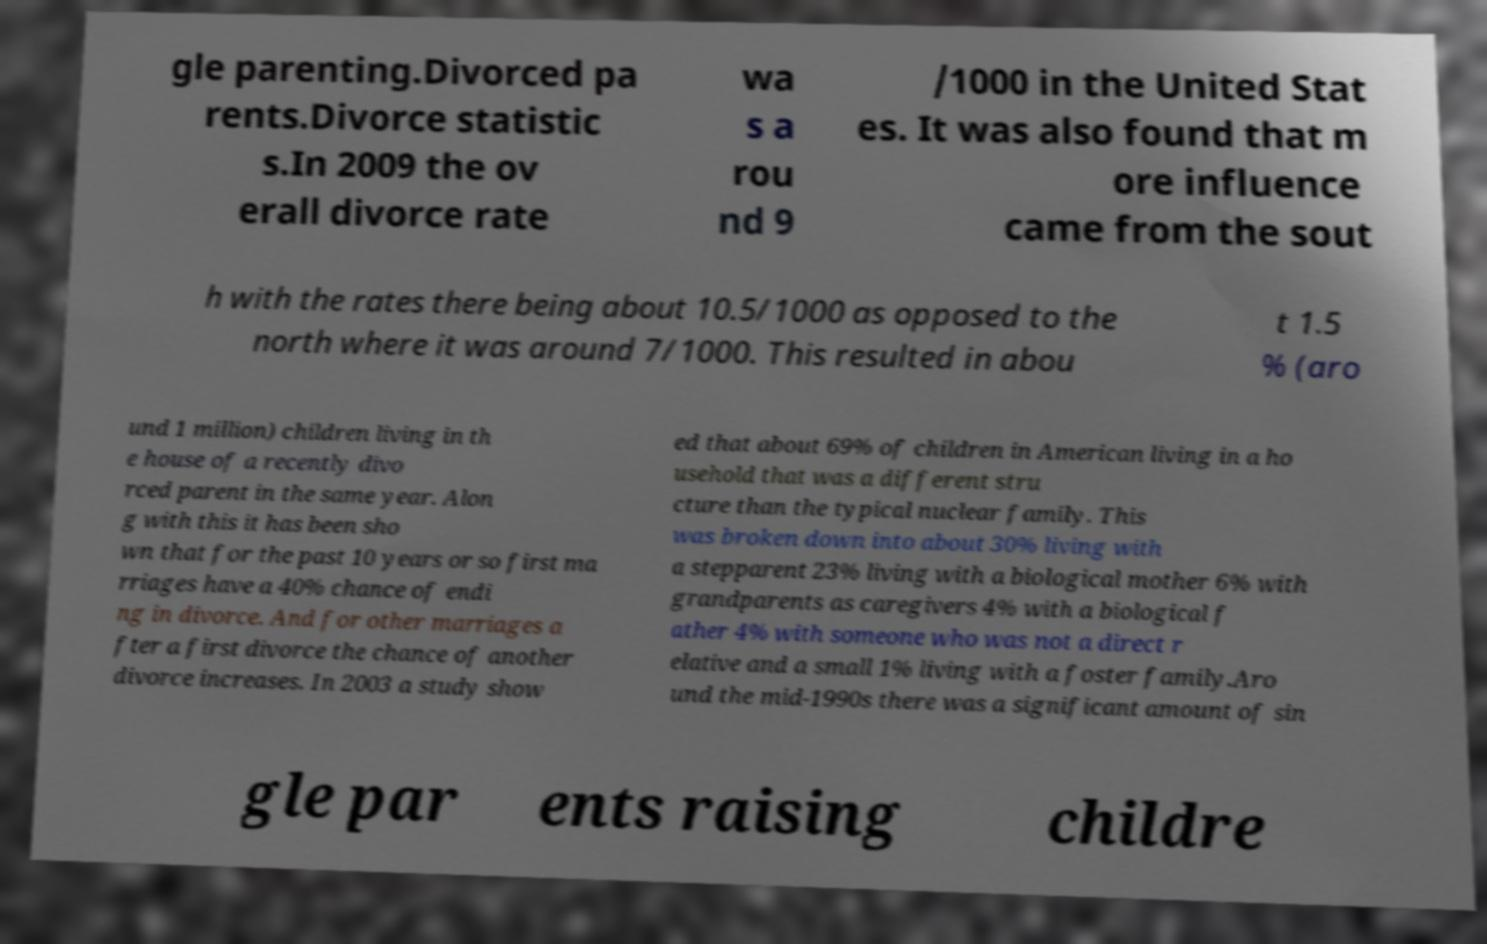For documentation purposes, I need the text within this image transcribed. Could you provide that? gle parenting.Divorced pa rents.Divorce statistic s.In 2009 the ov erall divorce rate wa s a rou nd 9 /1000 in the United Stat es. It was also found that m ore influence came from the sout h with the rates there being about 10.5/1000 as opposed to the north where it was around 7/1000. This resulted in abou t 1.5 % (aro und 1 million) children living in th e house of a recently divo rced parent in the same year. Alon g with this it has been sho wn that for the past 10 years or so first ma rriages have a 40% chance of endi ng in divorce. And for other marriages a fter a first divorce the chance of another divorce increases. In 2003 a study show ed that about 69% of children in American living in a ho usehold that was a different stru cture than the typical nuclear family. This was broken down into about 30% living with a stepparent 23% living with a biological mother 6% with grandparents as caregivers 4% with a biological f ather 4% with someone who was not a direct r elative and a small 1% living with a foster family.Aro und the mid-1990s there was a significant amount of sin gle par ents raising childre 